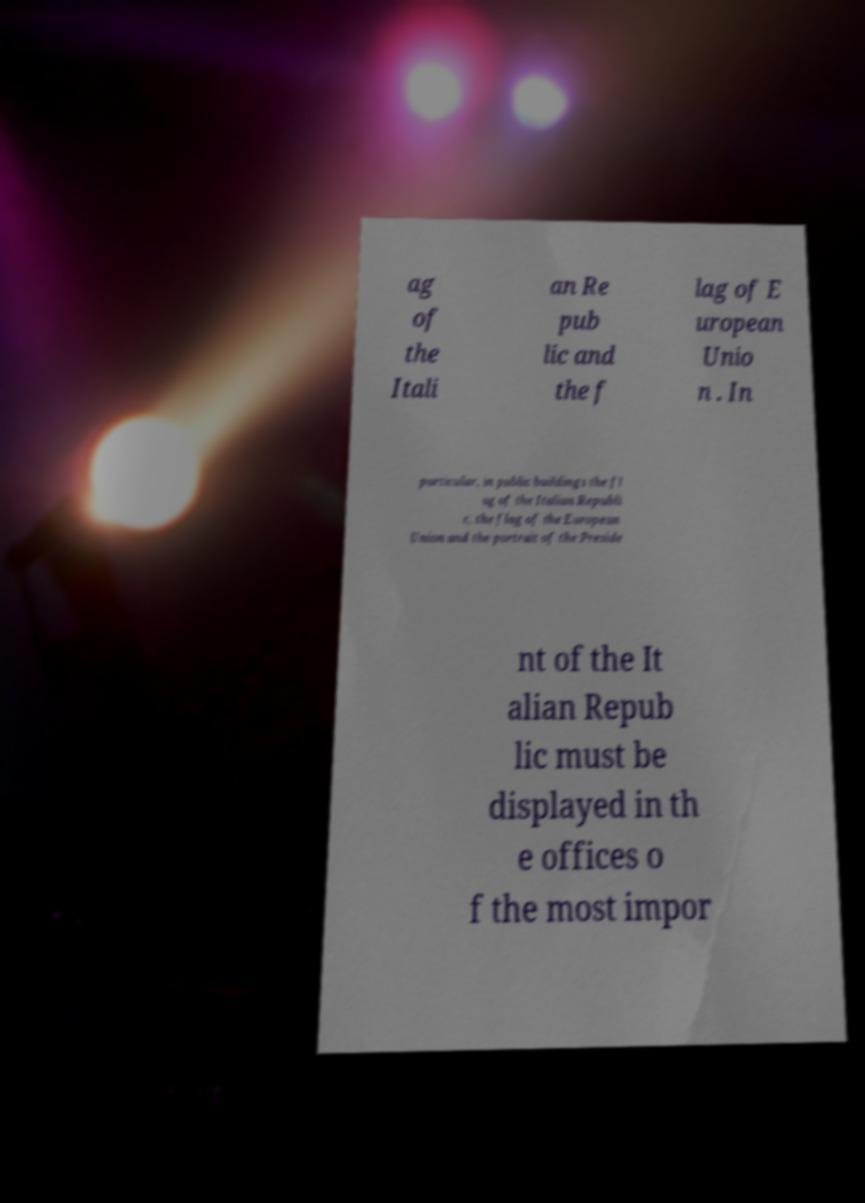Can you accurately transcribe the text from the provided image for me? ag of the Itali an Re pub lic and the f lag of E uropean Unio n . In particular, in public buildings the fl ag of the Italian Republi c, the flag of the European Union and the portrait of the Preside nt of the It alian Repub lic must be displayed in th e offices o f the most impor 